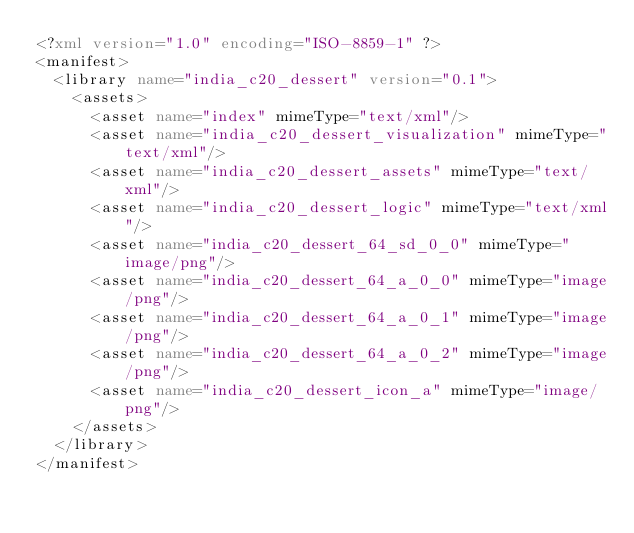<code> <loc_0><loc_0><loc_500><loc_500><_XML_><?xml version="1.0" encoding="ISO-8859-1" ?><manifest>
  <library name="india_c20_dessert" version="0.1">
    <assets>
      <asset name="index" mimeType="text/xml"/>
      <asset name="india_c20_dessert_visualization" mimeType="text/xml"/>
      <asset name="india_c20_dessert_assets" mimeType="text/xml"/>
      <asset name="india_c20_dessert_logic" mimeType="text/xml"/>
      <asset name="india_c20_dessert_64_sd_0_0" mimeType="image/png"/>
      <asset name="india_c20_dessert_64_a_0_0" mimeType="image/png"/>
      <asset name="india_c20_dessert_64_a_0_1" mimeType="image/png"/>
      <asset name="india_c20_dessert_64_a_0_2" mimeType="image/png"/>
      <asset name="india_c20_dessert_icon_a" mimeType="image/png"/>
    </assets>
  </library>
</manifest></code> 